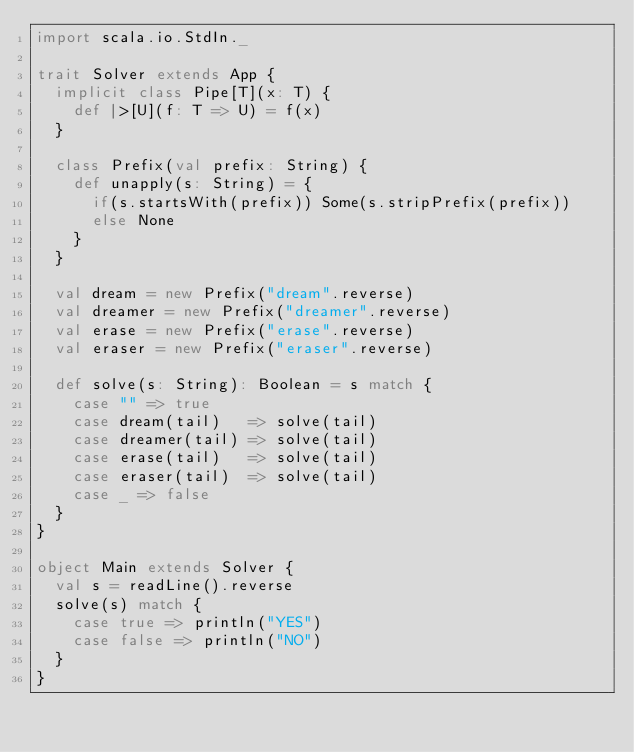Convert code to text. <code><loc_0><loc_0><loc_500><loc_500><_Scala_>import scala.io.StdIn._
 
trait Solver extends App {
  implicit class Pipe[T](x: T) {
    def |>[U](f: T => U) = f(x)
  }
 
  class Prefix(val prefix: String) {
    def unapply(s: String) = {
      if(s.startsWith(prefix)) Some(s.stripPrefix(prefix))
      else None
    }
  }
 
  val dream = new Prefix("dream".reverse)
  val dreamer = new Prefix("dreamer".reverse)
  val erase = new Prefix("erase".reverse)
  val eraser = new Prefix("eraser".reverse)
 
  def solve(s: String): Boolean = s match {
    case "" => true
    case dream(tail)   => solve(tail)
    case dreamer(tail) => solve(tail)
    case erase(tail)   => solve(tail)
    case eraser(tail)  => solve(tail)
    case _ => false
  }
}
 
object Main extends Solver {
  val s = readLine().reverse
  solve(s) match {
    case true => println("YES")
    case false => println("NO")
  }
}</code> 